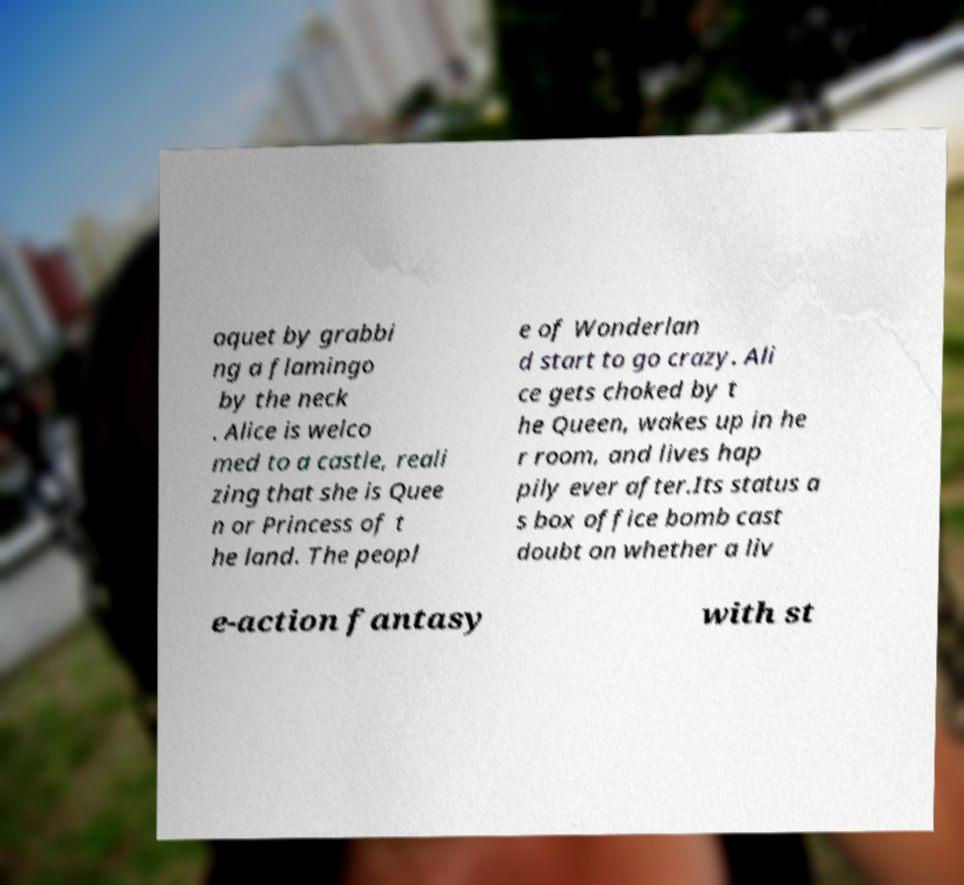Could you assist in decoding the text presented in this image and type it out clearly? oquet by grabbi ng a flamingo by the neck . Alice is welco med to a castle, reali zing that she is Quee n or Princess of t he land. The peopl e of Wonderlan d start to go crazy. Ali ce gets choked by t he Queen, wakes up in he r room, and lives hap pily ever after.Its status a s box office bomb cast doubt on whether a liv e-action fantasy with st 